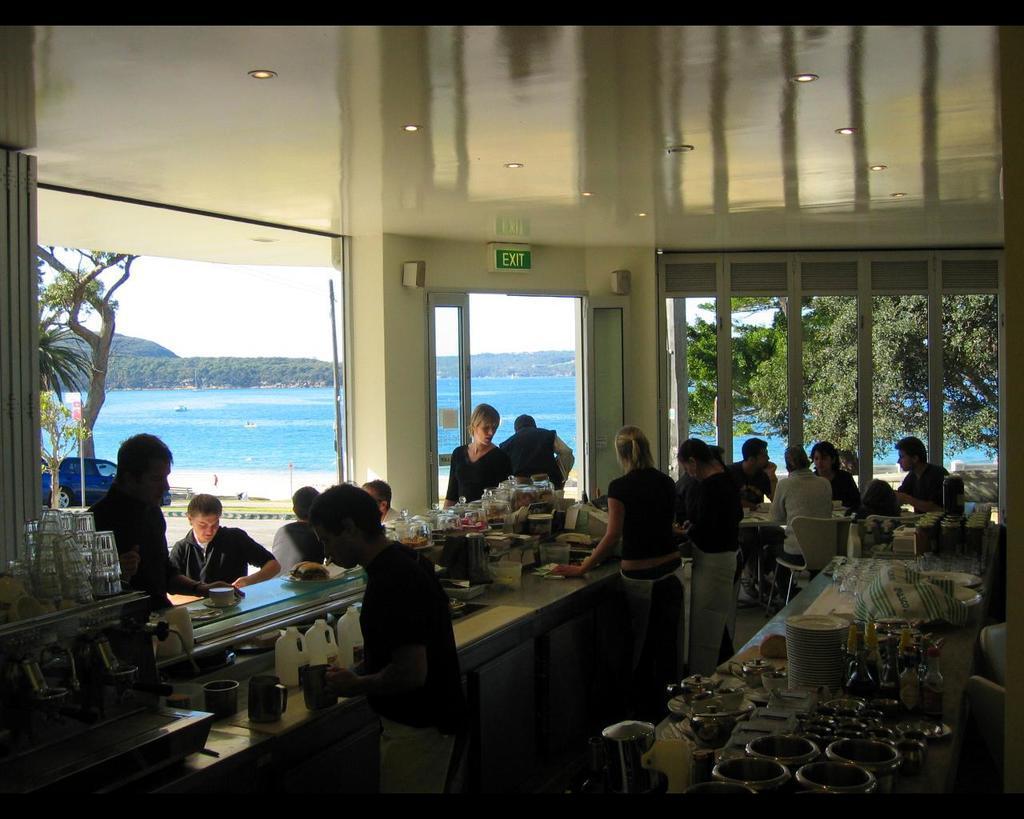Can you describe this image briefly? In this image we can see persons, counter top, tables, chairs, persons, glass tumblers, food, bowls, vessels, tissues, cups, door and windows. In the background we can see trees, water, hills, ship and sky. 